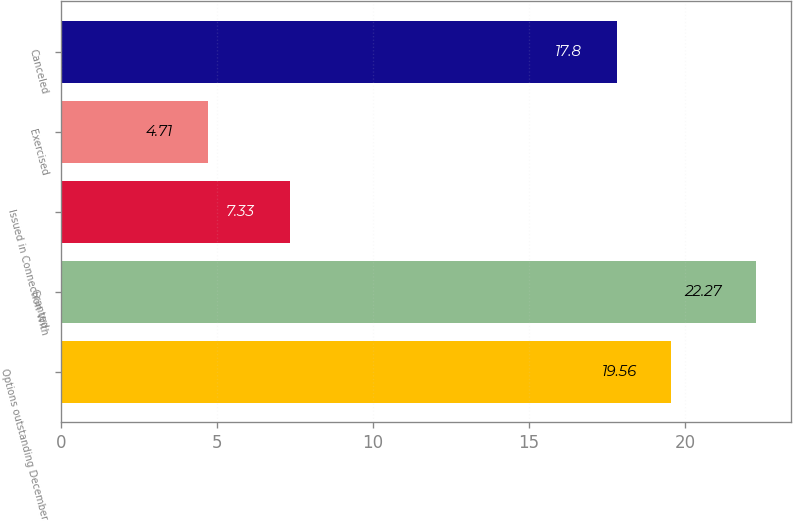Convert chart. <chart><loc_0><loc_0><loc_500><loc_500><bar_chart><fcel>Options outstanding December<fcel>Granted<fcel>Issued in Connection With<fcel>Exercised<fcel>Canceled<nl><fcel>19.56<fcel>22.27<fcel>7.33<fcel>4.71<fcel>17.8<nl></chart> 